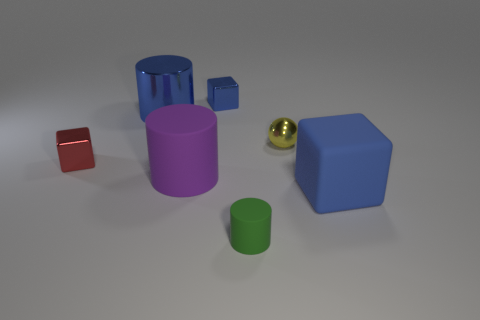Is the color of the matte block the same as the large metal cylinder?
Your answer should be compact. Yes. How many other cubes have the same color as the large cube?
Provide a succinct answer. 1. Does the tiny sphere have the same material as the big purple object?
Your response must be concise. No. Is the shape of the yellow thing the same as the red object?
Your answer should be compact. No. Are there the same number of cylinders that are in front of the purple matte cylinder and large metal cylinders to the left of the blue cylinder?
Your response must be concise. No. What color is the large cylinder that is the same material as the small green cylinder?
Your answer should be very brief. Purple. How many large blue objects are made of the same material as the purple cylinder?
Provide a succinct answer. 1. Does the metallic block that is behind the red shiny block have the same color as the large metallic cylinder?
Provide a succinct answer. Yes. What number of other shiny objects have the same shape as the red thing?
Give a very brief answer. 1. Is the number of small yellow things that are left of the blue shiny cylinder the same as the number of big cyan blocks?
Your answer should be compact. Yes. 